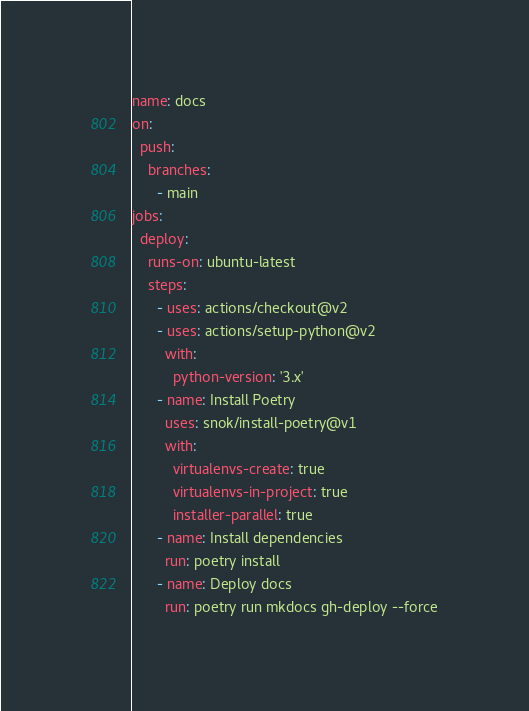<code> <loc_0><loc_0><loc_500><loc_500><_YAML_>name: docs
on:
  push:
    branches:
      - main
jobs:
  deploy:
    runs-on: ubuntu-latest
    steps:
      - uses: actions/checkout@v2
      - uses: actions/setup-python@v2
        with:
          python-version: '3.x'
      - name: Install Poetry
        uses: snok/install-poetry@v1
        with:
          virtualenvs-create: true
          virtualenvs-in-project: true
          installer-parallel: true
      - name: Install dependencies
        run: poetry install
      - name: Deploy docs
        run: poetry run mkdocs gh-deploy --force
</code> 